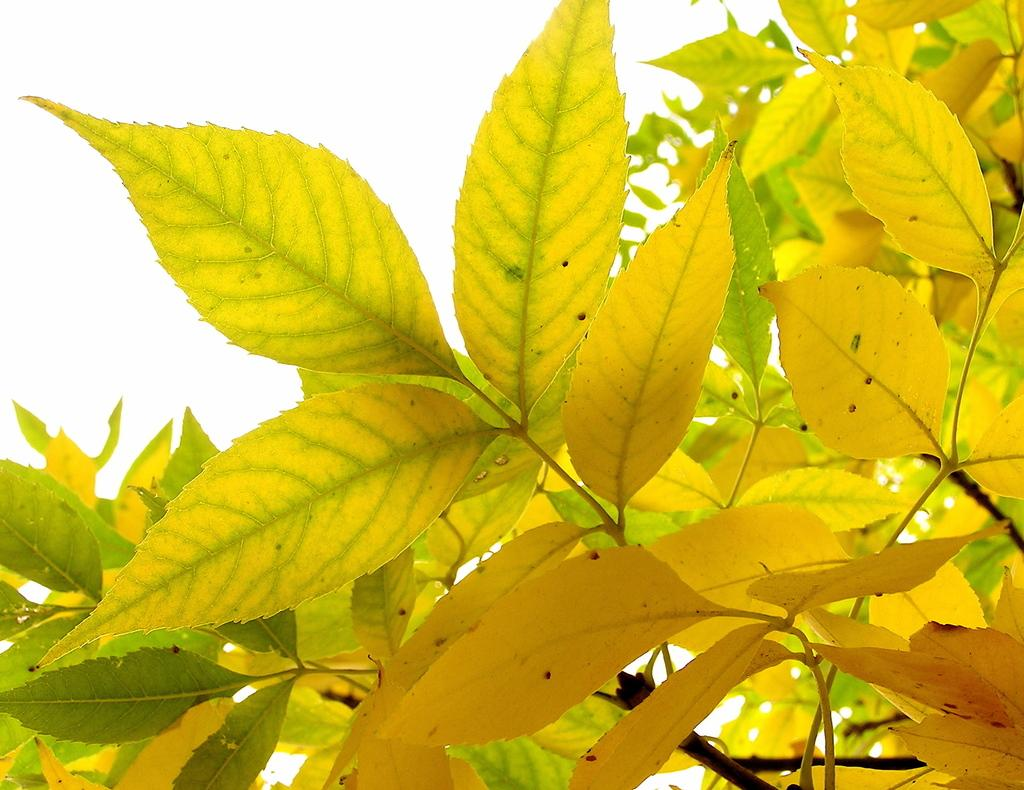What color are the leaves in the image? The leaves in the image are yellow. What part of the sky can be seen in the image? The sky is visible on the left side of the image. What type of bait is being used by the stranger in the image? There is no stranger present in the image, and therefore no bait or related activity can be observed. 